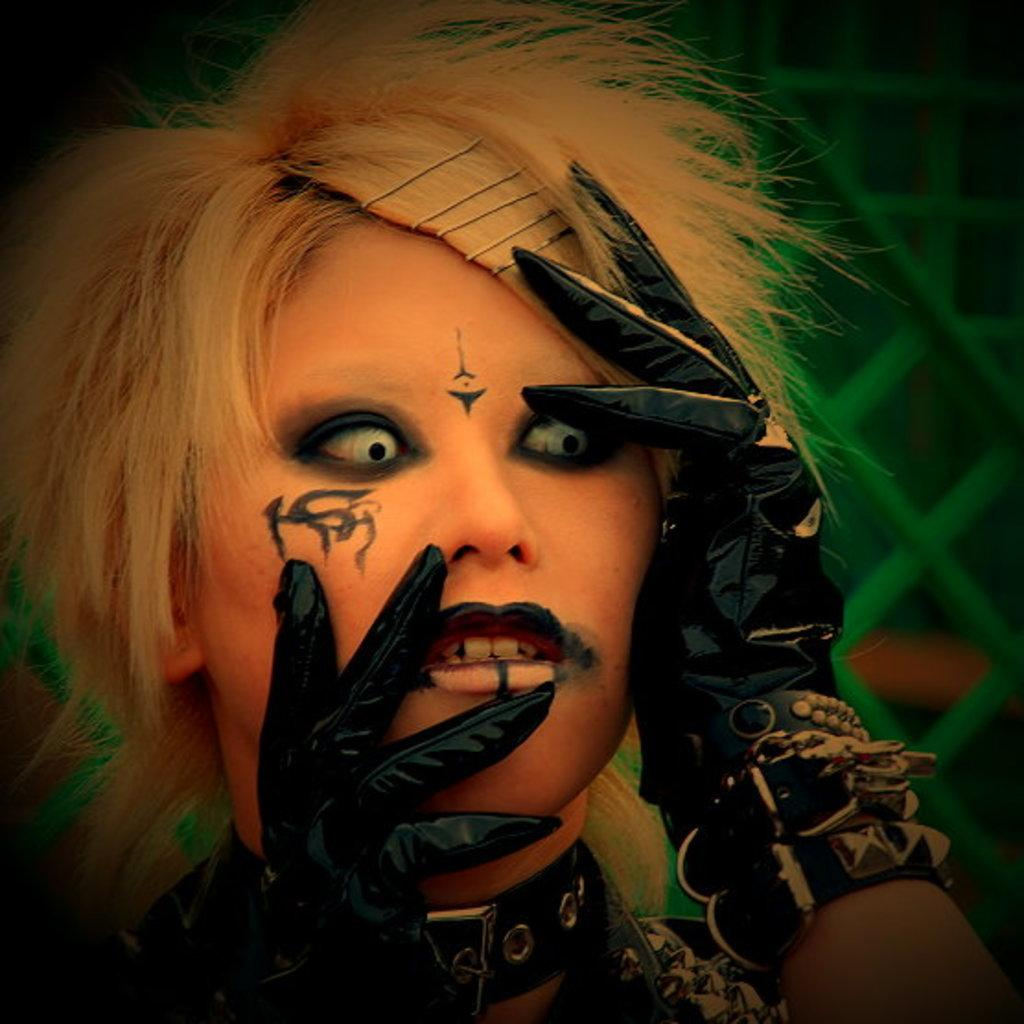Who is present in the image? There is a woman in the image. What accessories is the woman wearing on her hands? The woman is wearing gloves. What type of hair accessory is the woman wearing? The woman is wearing hairpins. What accessory is the woman wearing around her neck? The woman is wearing a neck belt. What type of mountain can be seen in the background of the image? There is no mountain present in the image; it features a woman wearing gloves, hairpins, and a neck belt. What kind of toy is the woman holding in the image? There is no toy present in the image; the woman is wearing accessories on her hands, hair, and neck. 